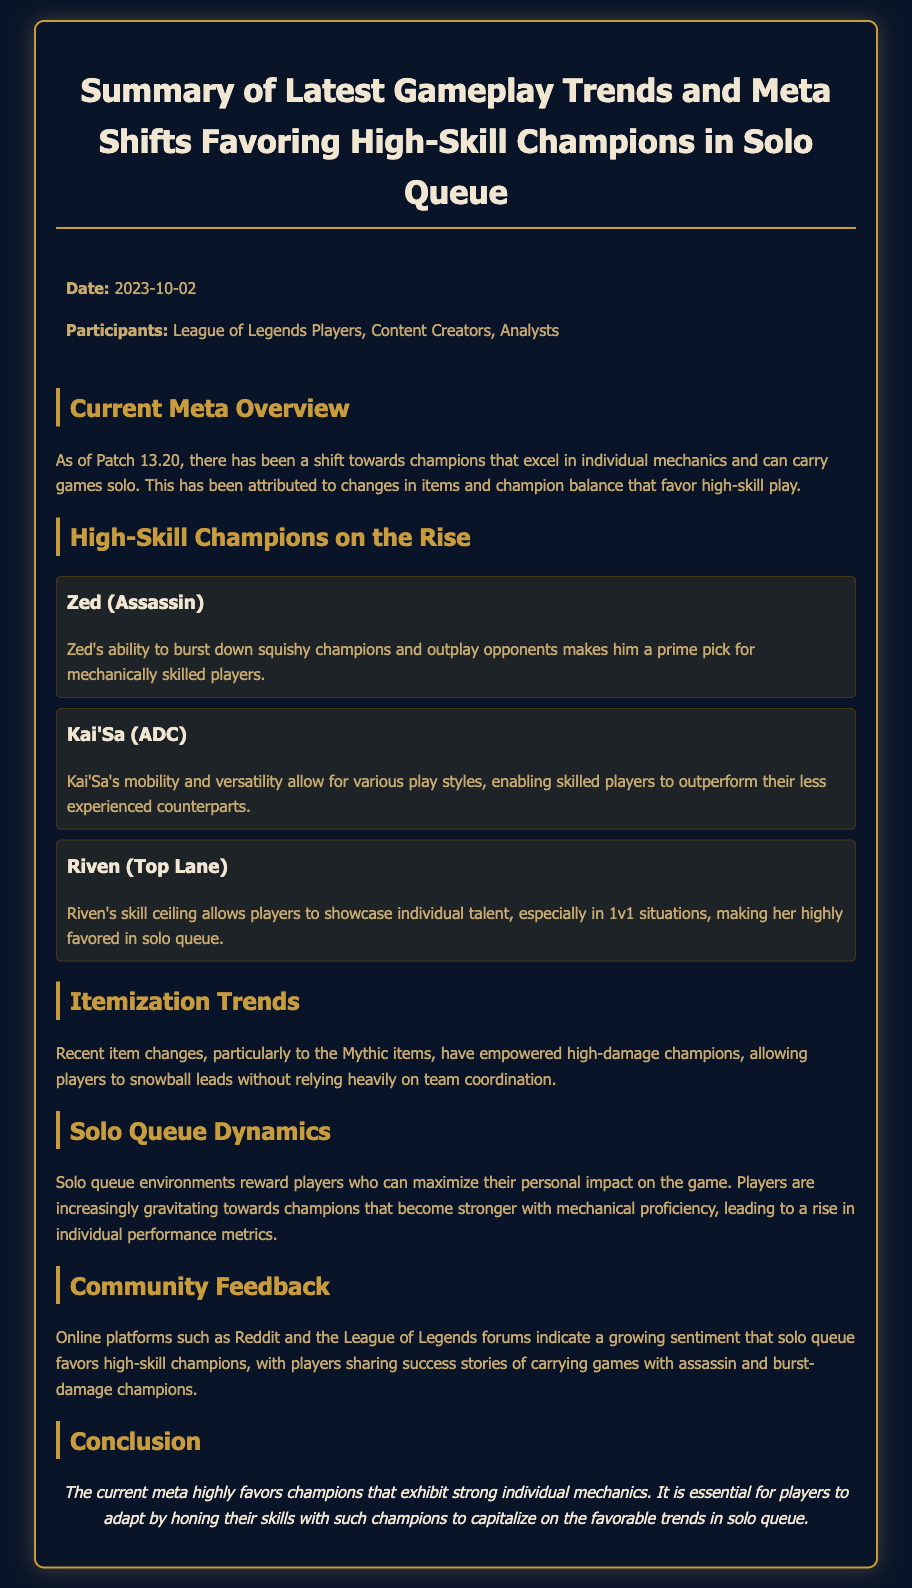what is the date of the meeting? The date of the meeting is mentioned at the beginning of the document as 2023-10-02.
Answer: 2023-10-02 who is one of the high-skill champions mentioned? The document lists several champions, including Zed, Kai'Sa, and Riven as high-skill champions.
Answer: Zed what type of champions are favored in the current meta? The document states that champions that excel in individual mechanics and can carry games solo are favored in the current meta.
Answer: High-skill champions what has empowered high-damage champions according to the document? The document mentions recent item changes, particularly to the Mythic items, have empowered high-damage champions.
Answer: Mythic items what do players share success stories about? Community feedback indicates that players share success stories of carrying games with assassin and burst-damage champions.
Answer: Assassin champions what environment rewards players who maximize personal impact? The document describes the solo queue environment as one that rewards players who can maximize their personal impact on the game.
Answer: Solo queue how does the current meta trend affect player skill development? The conclusion states it is essential for players to adapt by honing their skills with high-skill champions to capitalize on favorable trends.
Answer: Hone their skills which participant group was present in the meeting? The meeting participants included League of Legends Players, Content Creators, and Analysts, as stated in the document.
Answer: Analysts 